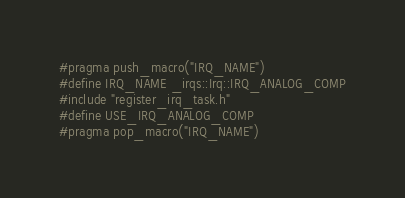Convert code to text. <code><loc_0><loc_0><loc_500><loc_500><_C_>#pragma push_macro("IRQ_NAME")
#define IRQ_NAME _irqs::Irq::IRQ_ANALOG_COMP
#include "register_irq_task.h"
#define USE_IRQ_ANALOG_COMP
#pragma pop_macro("IRQ_NAME")
</code> 